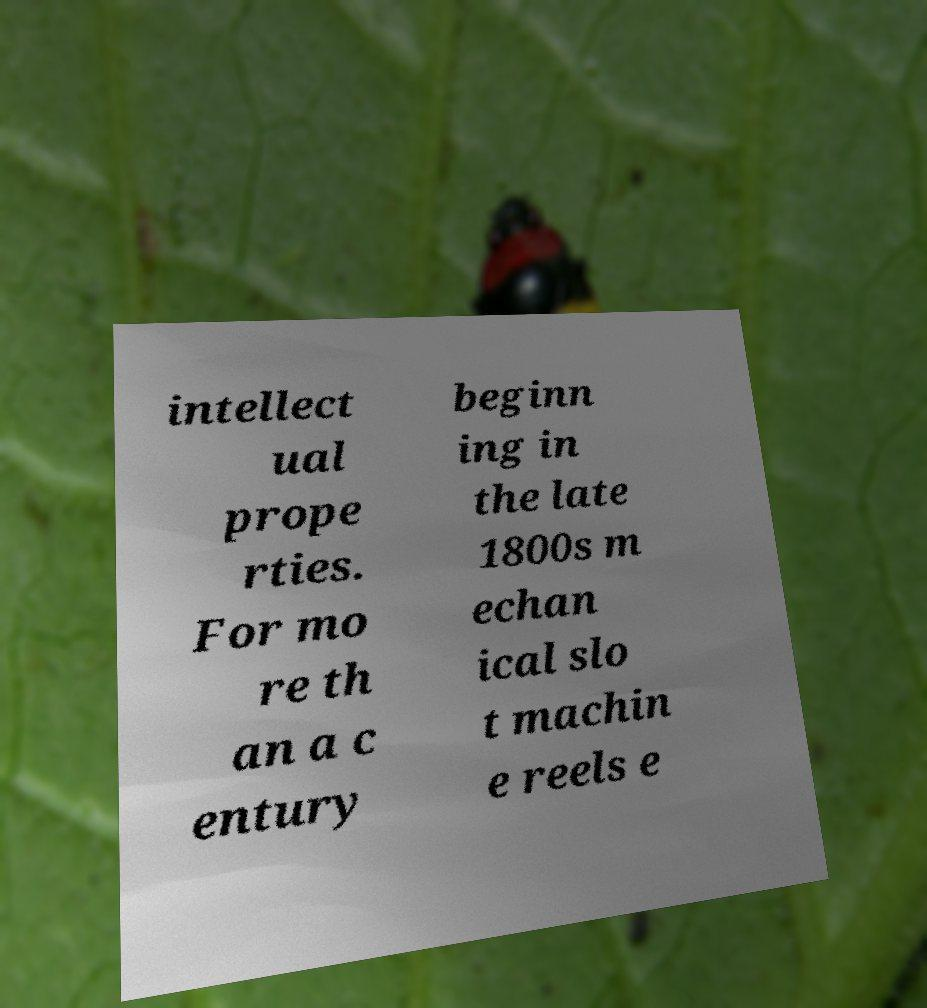What messages or text are displayed in this image? I need them in a readable, typed format. intellect ual prope rties. For mo re th an a c entury beginn ing in the late 1800s m echan ical slo t machin e reels e 